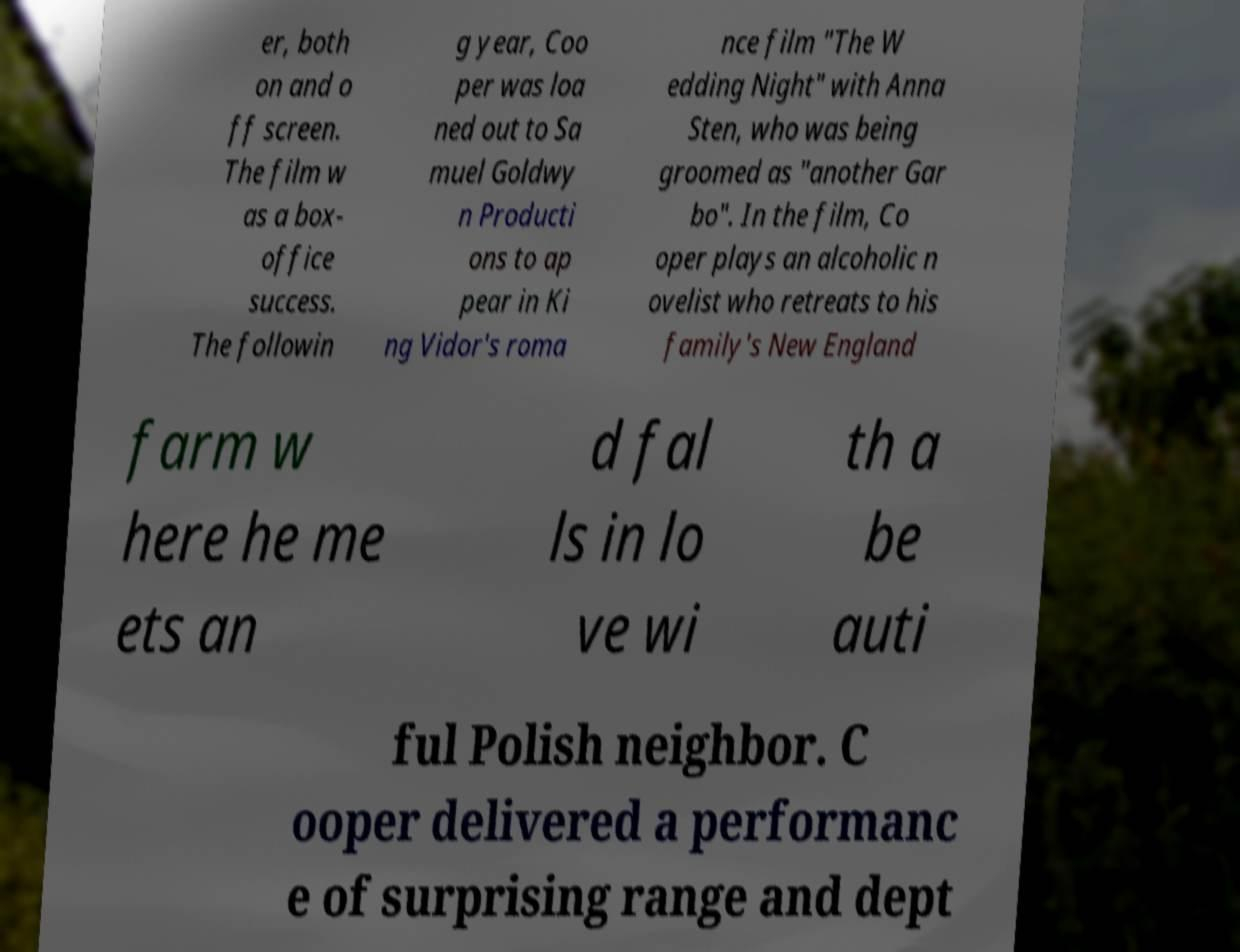Could you assist in decoding the text presented in this image and type it out clearly? er, both on and o ff screen. The film w as a box- office success. The followin g year, Coo per was loa ned out to Sa muel Goldwy n Producti ons to ap pear in Ki ng Vidor's roma nce film "The W edding Night" with Anna Sten, who was being groomed as "another Gar bo". In the film, Co oper plays an alcoholic n ovelist who retreats to his family's New England farm w here he me ets an d fal ls in lo ve wi th a be auti ful Polish neighbor. C ooper delivered a performanc e of surprising range and dept 